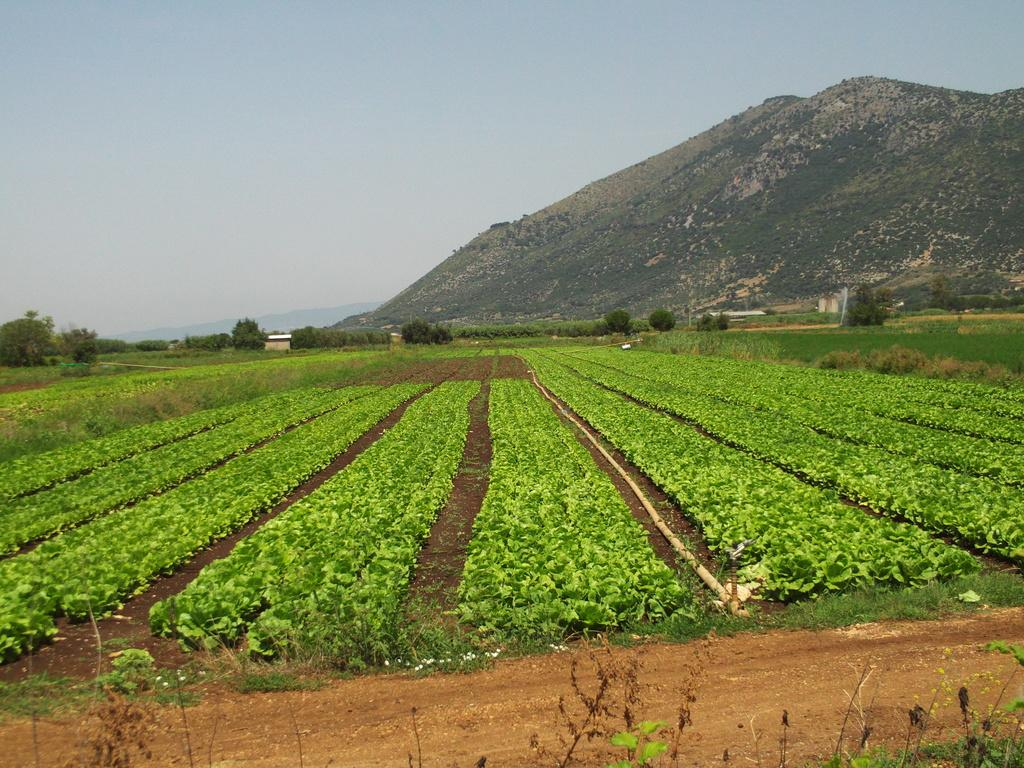What type of vegetation can be seen in the image? There are green plants and trees in the image. What is the ground made of in the image? There is mud in the image. What structure is present in the image? There is a pipe in the image. What type of geographical feature can be seen in the image? There are mountains in the image. What is the color of the sky in the image? The sky is a combination of white and blue colors. What type of straw is used to decorate the cakes in the image? There are no cakes or straws present in the image. What is the shock value of the image? The image does not have a shock value, as it depicts natural elements such as plants, mud, trees, a pipe, mountains, and the sky. 